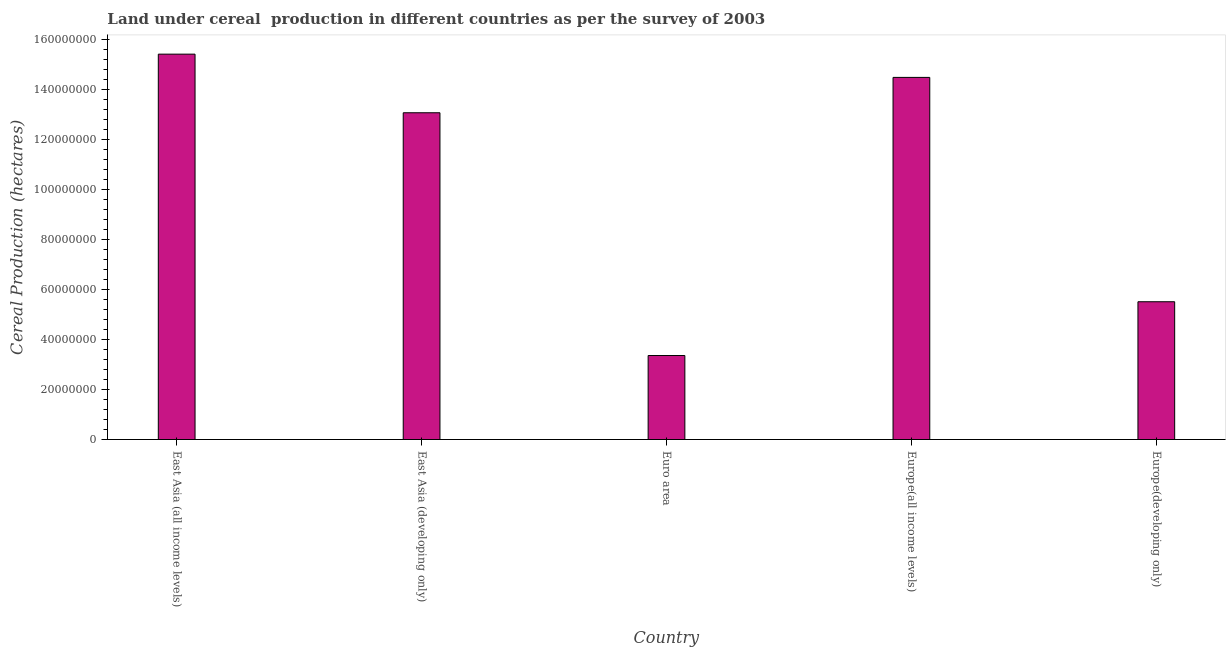What is the title of the graph?
Provide a short and direct response. Land under cereal  production in different countries as per the survey of 2003. What is the label or title of the Y-axis?
Provide a succinct answer. Cereal Production (hectares). What is the land under cereal production in Europe(developing only)?
Offer a very short reply. 5.51e+07. Across all countries, what is the maximum land under cereal production?
Offer a terse response. 1.54e+08. Across all countries, what is the minimum land under cereal production?
Your answer should be very brief. 3.36e+07. In which country was the land under cereal production maximum?
Ensure brevity in your answer.  East Asia (all income levels). What is the sum of the land under cereal production?
Your response must be concise. 5.19e+08. What is the difference between the land under cereal production in Euro area and Europe(all income levels)?
Provide a succinct answer. -1.11e+08. What is the average land under cereal production per country?
Provide a succinct answer. 1.04e+08. What is the median land under cereal production?
Make the answer very short. 1.31e+08. In how many countries, is the land under cereal production greater than 120000000 hectares?
Give a very brief answer. 3. What is the ratio of the land under cereal production in Europe(all income levels) to that in Europe(developing only)?
Your response must be concise. 2.63. Is the land under cereal production in East Asia (developing only) less than that in Europe(all income levels)?
Provide a short and direct response. Yes. What is the difference between the highest and the second highest land under cereal production?
Make the answer very short. 9.31e+06. Is the sum of the land under cereal production in Euro area and Europe(developing only) greater than the maximum land under cereal production across all countries?
Offer a terse response. No. What is the difference between the highest and the lowest land under cereal production?
Make the answer very short. 1.21e+08. How many bars are there?
Ensure brevity in your answer.  5. Are all the bars in the graph horizontal?
Keep it short and to the point. No. What is the difference between two consecutive major ticks on the Y-axis?
Your response must be concise. 2.00e+07. Are the values on the major ticks of Y-axis written in scientific E-notation?
Ensure brevity in your answer.  No. What is the Cereal Production (hectares) of East Asia (all income levels)?
Offer a terse response. 1.54e+08. What is the Cereal Production (hectares) of East Asia (developing only)?
Your response must be concise. 1.31e+08. What is the Cereal Production (hectares) of Euro area?
Ensure brevity in your answer.  3.36e+07. What is the Cereal Production (hectares) of Europe(all income levels)?
Your response must be concise. 1.45e+08. What is the Cereal Production (hectares) in Europe(developing only)?
Your answer should be compact. 5.51e+07. What is the difference between the Cereal Production (hectares) in East Asia (all income levels) and East Asia (developing only)?
Give a very brief answer. 2.35e+07. What is the difference between the Cereal Production (hectares) in East Asia (all income levels) and Euro area?
Offer a terse response. 1.21e+08. What is the difference between the Cereal Production (hectares) in East Asia (all income levels) and Europe(all income levels)?
Offer a very short reply. 9.31e+06. What is the difference between the Cereal Production (hectares) in East Asia (all income levels) and Europe(developing only)?
Your answer should be compact. 9.91e+07. What is the difference between the Cereal Production (hectares) in East Asia (developing only) and Euro area?
Offer a terse response. 9.71e+07. What is the difference between the Cereal Production (hectares) in East Asia (developing only) and Europe(all income levels)?
Keep it short and to the point. -1.42e+07. What is the difference between the Cereal Production (hectares) in East Asia (developing only) and Europe(developing only)?
Offer a terse response. 7.56e+07. What is the difference between the Cereal Production (hectares) in Euro area and Europe(all income levels)?
Provide a succinct answer. -1.11e+08. What is the difference between the Cereal Production (hectares) in Euro area and Europe(developing only)?
Offer a terse response. -2.15e+07. What is the difference between the Cereal Production (hectares) in Europe(all income levels) and Europe(developing only)?
Offer a very short reply. 8.98e+07. What is the ratio of the Cereal Production (hectares) in East Asia (all income levels) to that in East Asia (developing only)?
Keep it short and to the point. 1.18. What is the ratio of the Cereal Production (hectares) in East Asia (all income levels) to that in Euro area?
Offer a terse response. 4.59. What is the ratio of the Cereal Production (hectares) in East Asia (all income levels) to that in Europe(all income levels)?
Make the answer very short. 1.06. What is the ratio of the Cereal Production (hectares) in East Asia (all income levels) to that in Europe(developing only)?
Keep it short and to the point. 2.8. What is the ratio of the Cereal Production (hectares) in East Asia (developing only) to that in Euro area?
Your answer should be very brief. 3.89. What is the ratio of the Cereal Production (hectares) in East Asia (developing only) to that in Europe(all income levels)?
Keep it short and to the point. 0.9. What is the ratio of the Cereal Production (hectares) in East Asia (developing only) to that in Europe(developing only)?
Your response must be concise. 2.37. What is the ratio of the Cereal Production (hectares) in Euro area to that in Europe(all income levels)?
Offer a terse response. 0.23. What is the ratio of the Cereal Production (hectares) in Euro area to that in Europe(developing only)?
Keep it short and to the point. 0.61. What is the ratio of the Cereal Production (hectares) in Europe(all income levels) to that in Europe(developing only)?
Give a very brief answer. 2.63. 